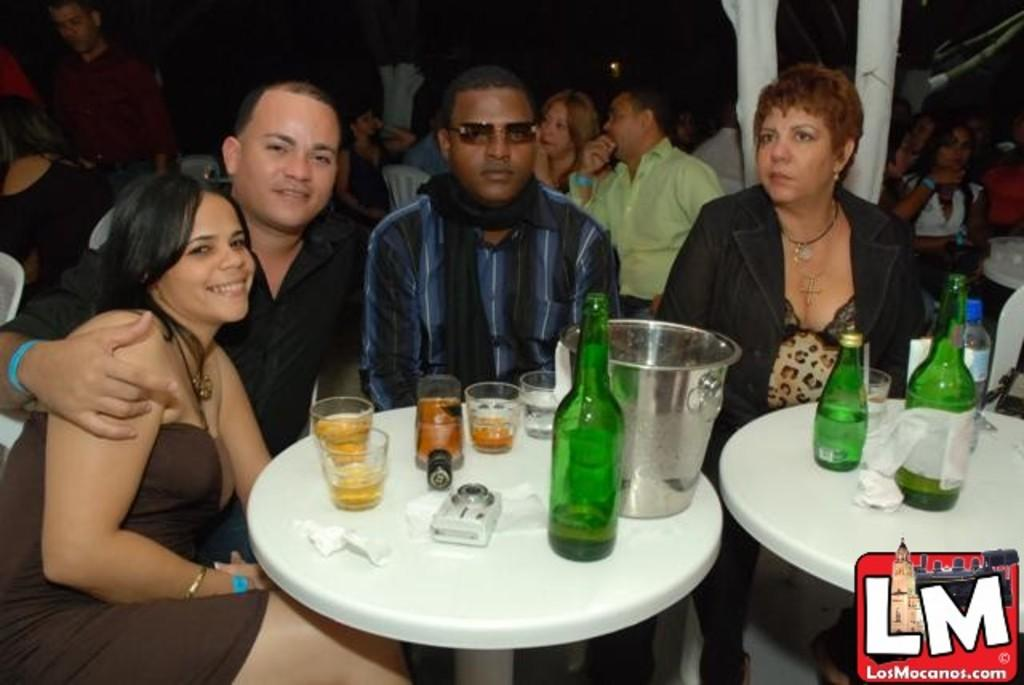How many people are sitting in front of the table in the image? There are four people sitting in front of the table in the image. What can be found on the table? There is a bottle and glasses on the table. Are there any other people visible in the image? Yes, there are more people sitting in the background. What type of dress is the person in the background wearing? There is no information about the clothing of the people in the image, so we cannot determine the type of dress worn by anyone in the background. 